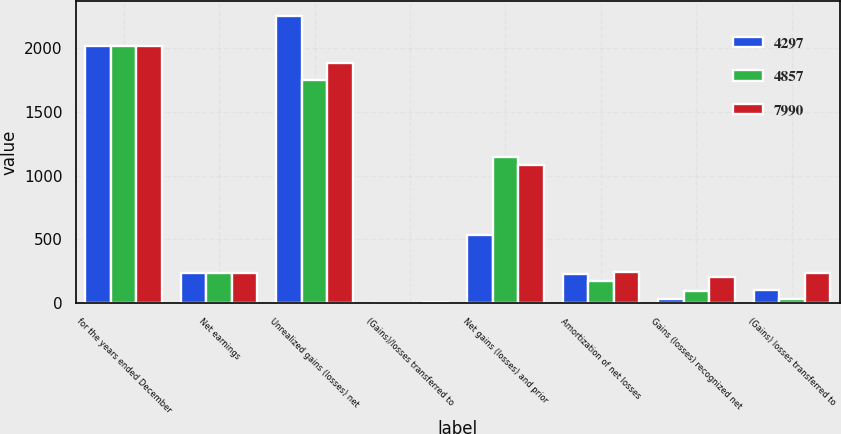Convert chart. <chart><loc_0><loc_0><loc_500><loc_500><stacked_bar_chart><ecel><fcel>for the years ended December<fcel>Net earnings<fcel>Unrealized gains (losses) net<fcel>(Gains)/losses transferred to<fcel>Net gains (losses) and prior<fcel>Amortization of net losses<fcel>Gains (losses) recognized net<fcel>(Gains) losses transferred to<nl><fcel>4297<fcel>2015<fcel>235<fcel>2248<fcel>1<fcel>536<fcel>227<fcel>38<fcel>102<nl><fcel>4857<fcel>2014<fcel>235<fcel>1746<fcel>5<fcel>1148<fcel>173<fcel>98<fcel>38<nl><fcel>7990<fcel>2013<fcel>235<fcel>1876<fcel>12<fcel>1079<fcel>243<fcel>206<fcel>235<nl></chart> 